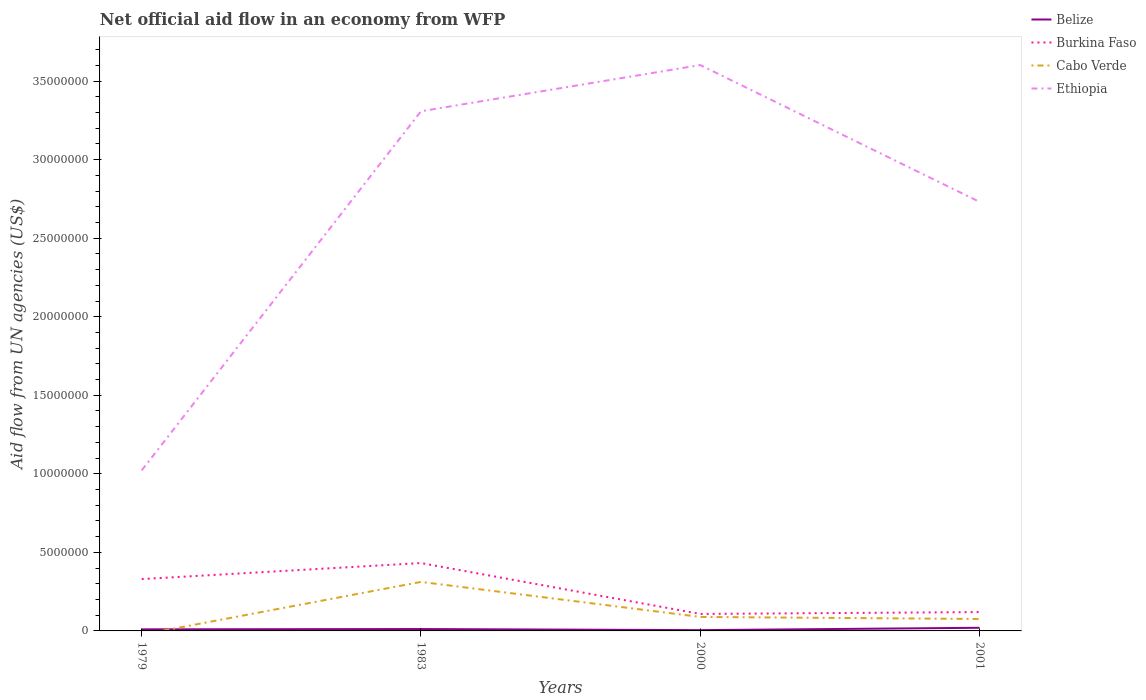Does the line corresponding to Cabo Verde intersect with the line corresponding to Belize?
Your answer should be very brief. Yes. Across all years, what is the maximum net official aid flow in Ethiopia?
Your answer should be very brief. 1.02e+07. What is the total net official aid flow in Burkina Faso in the graph?
Offer a terse response. 2.22e+06. What is the difference between the highest and the second highest net official aid flow in Burkina Faso?
Offer a terse response. 3.24e+06. What is the difference between the highest and the lowest net official aid flow in Belize?
Your response must be concise. 2. Is the net official aid flow in Burkina Faso strictly greater than the net official aid flow in Cabo Verde over the years?
Provide a succinct answer. No. How many lines are there?
Keep it short and to the point. 4. How many years are there in the graph?
Your answer should be very brief. 4. Does the graph contain grids?
Make the answer very short. No. How are the legend labels stacked?
Give a very brief answer. Vertical. What is the title of the graph?
Keep it short and to the point. Net official aid flow in an economy from WFP. Does "Israel" appear as one of the legend labels in the graph?
Your response must be concise. No. What is the label or title of the Y-axis?
Your response must be concise. Aid flow from UN agencies (US$). What is the Aid flow from UN agencies (US$) of Belize in 1979?
Your answer should be compact. 1.00e+05. What is the Aid flow from UN agencies (US$) in Burkina Faso in 1979?
Provide a short and direct response. 3.30e+06. What is the Aid flow from UN agencies (US$) of Ethiopia in 1979?
Your answer should be compact. 1.02e+07. What is the Aid flow from UN agencies (US$) in Burkina Faso in 1983?
Keep it short and to the point. 4.32e+06. What is the Aid flow from UN agencies (US$) in Cabo Verde in 1983?
Your response must be concise. 3.12e+06. What is the Aid flow from UN agencies (US$) in Ethiopia in 1983?
Your answer should be compact. 3.31e+07. What is the Aid flow from UN agencies (US$) of Belize in 2000?
Ensure brevity in your answer.  5.00e+04. What is the Aid flow from UN agencies (US$) of Burkina Faso in 2000?
Ensure brevity in your answer.  1.08e+06. What is the Aid flow from UN agencies (US$) of Cabo Verde in 2000?
Provide a short and direct response. 8.90e+05. What is the Aid flow from UN agencies (US$) of Ethiopia in 2000?
Ensure brevity in your answer.  3.60e+07. What is the Aid flow from UN agencies (US$) of Burkina Faso in 2001?
Your answer should be compact. 1.20e+06. What is the Aid flow from UN agencies (US$) in Cabo Verde in 2001?
Give a very brief answer. 7.60e+05. What is the Aid flow from UN agencies (US$) in Ethiopia in 2001?
Your response must be concise. 2.73e+07. Across all years, what is the maximum Aid flow from UN agencies (US$) in Belize?
Provide a short and direct response. 2.00e+05. Across all years, what is the maximum Aid flow from UN agencies (US$) of Burkina Faso?
Offer a very short reply. 4.32e+06. Across all years, what is the maximum Aid flow from UN agencies (US$) of Cabo Verde?
Offer a very short reply. 3.12e+06. Across all years, what is the maximum Aid flow from UN agencies (US$) of Ethiopia?
Ensure brevity in your answer.  3.60e+07. Across all years, what is the minimum Aid flow from UN agencies (US$) of Belize?
Provide a succinct answer. 5.00e+04. Across all years, what is the minimum Aid flow from UN agencies (US$) of Burkina Faso?
Make the answer very short. 1.08e+06. Across all years, what is the minimum Aid flow from UN agencies (US$) of Cabo Verde?
Your answer should be compact. 0. Across all years, what is the minimum Aid flow from UN agencies (US$) in Ethiopia?
Keep it short and to the point. 1.02e+07. What is the total Aid flow from UN agencies (US$) of Burkina Faso in the graph?
Your answer should be very brief. 9.90e+06. What is the total Aid flow from UN agencies (US$) of Cabo Verde in the graph?
Provide a short and direct response. 4.77e+06. What is the total Aid flow from UN agencies (US$) of Ethiopia in the graph?
Offer a terse response. 1.07e+08. What is the difference between the Aid flow from UN agencies (US$) of Burkina Faso in 1979 and that in 1983?
Your response must be concise. -1.02e+06. What is the difference between the Aid flow from UN agencies (US$) in Ethiopia in 1979 and that in 1983?
Your answer should be very brief. -2.29e+07. What is the difference between the Aid flow from UN agencies (US$) of Burkina Faso in 1979 and that in 2000?
Ensure brevity in your answer.  2.22e+06. What is the difference between the Aid flow from UN agencies (US$) in Ethiopia in 1979 and that in 2000?
Provide a short and direct response. -2.58e+07. What is the difference between the Aid flow from UN agencies (US$) in Burkina Faso in 1979 and that in 2001?
Give a very brief answer. 2.10e+06. What is the difference between the Aid flow from UN agencies (US$) in Ethiopia in 1979 and that in 2001?
Your answer should be very brief. -1.71e+07. What is the difference between the Aid flow from UN agencies (US$) of Belize in 1983 and that in 2000?
Offer a terse response. 7.00e+04. What is the difference between the Aid flow from UN agencies (US$) in Burkina Faso in 1983 and that in 2000?
Keep it short and to the point. 3.24e+06. What is the difference between the Aid flow from UN agencies (US$) in Cabo Verde in 1983 and that in 2000?
Your answer should be compact. 2.23e+06. What is the difference between the Aid flow from UN agencies (US$) of Ethiopia in 1983 and that in 2000?
Keep it short and to the point. -2.94e+06. What is the difference between the Aid flow from UN agencies (US$) in Burkina Faso in 1983 and that in 2001?
Ensure brevity in your answer.  3.12e+06. What is the difference between the Aid flow from UN agencies (US$) of Cabo Verde in 1983 and that in 2001?
Ensure brevity in your answer.  2.36e+06. What is the difference between the Aid flow from UN agencies (US$) of Ethiopia in 1983 and that in 2001?
Make the answer very short. 5.77e+06. What is the difference between the Aid flow from UN agencies (US$) in Cabo Verde in 2000 and that in 2001?
Your answer should be compact. 1.30e+05. What is the difference between the Aid flow from UN agencies (US$) of Ethiopia in 2000 and that in 2001?
Provide a short and direct response. 8.71e+06. What is the difference between the Aid flow from UN agencies (US$) in Belize in 1979 and the Aid flow from UN agencies (US$) in Burkina Faso in 1983?
Your response must be concise. -4.22e+06. What is the difference between the Aid flow from UN agencies (US$) in Belize in 1979 and the Aid flow from UN agencies (US$) in Cabo Verde in 1983?
Your answer should be compact. -3.02e+06. What is the difference between the Aid flow from UN agencies (US$) of Belize in 1979 and the Aid flow from UN agencies (US$) of Ethiopia in 1983?
Give a very brief answer. -3.30e+07. What is the difference between the Aid flow from UN agencies (US$) in Burkina Faso in 1979 and the Aid flow from UN agencies (US$) in Cabo Verde in 1983?
Ensure brevity in your answer.  1.80e+05. What is the difference between the Aid flow from UN agencies (US$) of Burkina Faso in 1979 and the Aid flow from UN agencies (US$) of Ethiopia in 1983?
Your answer should be compact. -2.98e+07. What is the difference between the Aid flow from UN agencies (US$) in Belize in 1979 and the Aid flow from UN agencies (US$) in Burkina Faso in 2000?
Offer a terse response. -9.80e+05. What is the difference between the Aid flow from UN agencies (US$) in Belize in 1979 and the Aid flow from UN agencies (US$) in Cabo Verde in 2000?
Give a very brief answer. -7.90e+05. What is the difference between the Aid flow from UN agencies (US$) of Belize in 1979 and the Aid flow from UN agencies (US$) of Ethiopia in 2000?
Offer a terse response. -3.59e+07. What is the difference between the Aid flow from UN agencies (US$) in Burkina Faso in 1979 and the Aid flow from UN agencies (US$) in Cabo Verde in 2000?
Give a very brief answer. 2.41e+06. What is the difference between the Aid flow from UN agencies (US$) of Burkina Faso in 1979 and the Aid flow from UN agencies (US$) of Ethiopia in 2000?
Provide a short and direct response. -3.27e+07. What is the difference between the Aid flow from UN agencies (US$) of Belize in 1979 and the Aid flow from UN agencies (US$) of Burkina Faso in 2001?
Provide a short and direct response. -1.10e+06. What is the difference between the Aid flow from UN agencies (US$) in Belize in 1979 and the Aid flow from UN agencies (US$) in Cabo Verde in 2001?
Your answer should be very brief. -6.60e+05. What is the difference between the Aid flow from UN agencies (US$) of Belize in 1979 and the Aid flow from UN agencies (US$) of Ethiopia in 2001?
Make the answer very short. -2.72e+07. What is the difference between the Aid flow from UN agencies (US$) of Burkina Faso in 1979 and the Aid flow from UN agencies (US$) of Cabo Verde in 2001?
Make the answer very short. 2.54e+06. What is the difference between the Aid flow from UN agencies (US$) of Burkina Faso in 1979 and the Aid flow from UN agencies (US$) of Ethiopia in 2001?
Your answer should be compact. -2.40e+07. What is the difference between the Aid flow from UN agencies (US$) in Belize in 1983 and the Aid flow from UN agencies (US$) in Burkina Faso in 2000?
Keep it short and to the point. -9.60e+05. What is the difference between the Aid flow from UN agencies (US$) of Belize in 1983 and the Aid flow from UN agencies (US$) of Cabo Verde in 2000?
Offer a terse response. -7.70e+05. What is the difference between the Aid flow from UN agencies (US$) in Belize in 1983 and the Aid flow from UN agencies (US$) in Ethiopia in 2000?
Make the answer very short. -3.59e+07. What is the difference between the Aid flow from UN agencies (US$) in Burkina Faso in 1983 and the Aid flow from UN agencies (US$) in Cabo Verde in 2000?
Keep it short and to the point. 3.43e+06. What is the difference between the Aid flow from UN agencies (US$) in Burkina Faso in 1983 and the Aid flow from UN agencies (US$) in Ethiopia in 2000?
Provide a succinct answer. -3.17e+07. What is the difference between the Aid flow from UN agencies (US$) in Cabo Verde in 1983 and the Aid flow from UN agencies (US$) in Ethiopia in 2000?
Ensure brevity in your answer.  -3.29e+07. What is the difference between the Aid flow from UN agencies (US$) of Belize in 1983 and the Aid flow from UN agencies (US$) of Burkina Faso in 2001?
Make the answer very short. -1.08e+06. What is the difference between the Aid flow from UN agencies (US$) in Belize in 1983 and the Aid flow from UN agencies (US$) in Cabo Verde in 2001?
Offer a very short reply. -6.40e+05. What is the difference between the Aid flow from UN agencies (US$) in Belize in 1983 and the Aid flow from UN agencies (US$) in Ethiopia in 2001?
Offer a very short reply. -2.72e+07. What is the difference between the Aid flow from UN agencies (US$) in Burkina Faso in 1983 and the Aid flow from UN agencies (US$) in Cabo Verde in 2001?
Offer a very short reply. 3.56e+06. What is the difference between the Aid flow from UN agencies (US$) of Burkina Faso in 1983 and the Aid flow from UN agencies (US$) of Ethiopia in 2001?
Provide a succinct answer. -2.30e+07. What is the difference between the Aid flow from UN agencies (US$) in Cabo Verde in 1983 and the Aid flow from UN agencies (US$) in Ethiopia in 2001?
Your response must be concise. -2.42e+07. What is the difference between the Aid flow from UN agencies (US$) of Belize in 2000 and the Aid flow from UN agencies (US$) of Burkina Faso in 2001?
Offer a very short reply. -1.15e+06. What is the difference between the Aid flow from UN agencies (US$) of Belize in 2000 and the Aid flow from UN agencies (US$) of Cabo Verde in 2001?
Your answer should be very brief. -7.10e+05. What is the difference between the Aid flow from UN agencies (US$) in Belize in 2000 and the Aid flow from UN agencies (US$) in Ethiopia in 2001?
Make the answer very short. -2.73e+07. What is the difference between the Aid flow from UN agencies (US$) of Burkina Faso in 2000 and the Aid flow from UN agencies (US$) of Ethiopia in 2001?
Offer a very short reply. -2.62e+07. What is the difference between the Aid flow from UN agencies (US$) in Cabo Verde in 2000 and the Aid flow from UN agencies (US$) in Ethiopia in 2001?
Provide a short and direct response. -2.64e+07. What is the average Aid flow from UN agencies (US$) of Belize per year?
Make the answer very short. 1.18e+05. What is the average Aid flow from UN agencies (US$) in Burkina Faso per year?
Your answer should be very brief. 2.48e+06. What is the average Aid flow from UN agencies (US$) of Cabo Verde per year?
Make the answer very short. 1.19e+06. What is the average Aid flow from UN agencies (US$) of Ethiopia per year?
Provide a succinct answer. 2.67e+07. In the year 1979, what is the difference between the Aid flow from UN agencies (US$) in Belize and Aid flow from UN agencies (US$) in Burkina Faso?
Provide a short and direct response. -3.20e+06. In the year 1979, what is the difference between the Aid flow from UN agencies (US$) of Belize and Aid flow from UN agencies (US$) of Ethiopia?
Ensure brevity in your answer.  -1.01e+07. In the year 1979, what is the difference between the Aid flow from UN agencies (US$) of Burkina Faso and Aid flow from UN agencies (US$) of Ethiopia?
Give a very brief answer. -6.92e+06. In the year 1983, what is the difference between the Aid flow from UN agencies (US$) of Belize and Aid flow from UN agencies (US$) of Burkina Faso?
Make the answer very short. -4.20e+06. In the year 1983, what is the difference between the Aid flow from UN agencies (US$) in Belize and Aid flow from UN agencies (US$) in Ethiopia?
Keep it short and to the point. -3.30e+07. In the year 1983, what is the difference between the Aid flow from UN agencies (US$) of Burkina Faso and Aid flow from UN agencies (US$) of Cabo Verde?
Make the answer very short. 1.20e+06. In the year 1983, what is the difference between the Aid flow from UN agencies (US$) of Burkina Faso and Aid flow from UN agencies (US$) of Ethiopia?
Keep it short and to the point. -2.88e+07. In the year 1983, what is the difference between the Aid flow from UN agencies (US$) of Cabo Verde and Aid flow from UN agencies (US$) of Ethiopia?
Keep it short and to the point. -3.00e+07. In the year 2000, what is the difference between the Aid flow from UN agencies (US$) in Belize and Aid flow from UN agencies (US$) in Burkina Faso?
Make the answer very short. -1.03e+06. In the year 2000, what is the difference between the Aid flow from UN agencies (US$) in Belize and Aid flow from UN agencies (US$) in Cabo Verde?
Your response must be concise. -8.40e+05. In the year 2000, what is the difference between the Aid flow from UN agencies (US$) in Belize and Aid flow from UN agencies (US$) in Ethiopia?
Provide a short and direct response. -3.60e+07. In the year 2000, what is the difference between the Aid flow from UN agencies (US$) of Burkina Faso and Aid flow from UN agencies (US$) of Ethiopia?
Ensure brevity in your answer.  -3.49e+07. In the year 2000, what is the difference between the Aid flow from UN agencies (US$) in Cabo Verde and Aid flow from UN agencies (US$) in Ethiopia?
Your answer should be very brief. -3.51e+07. In the year 2001, what is the difference between the Aid flow from UN agencies (US$) of Belize and Aid flow from UN agencies (US$) of Burkina Faso?
Offer a very short reply. -1.00e+06. In the year 2001, what is the difference between the Aid flow from UN agencies (US$) in Belize and Aid flow from UN agencies (US$) in Cabo Verde?
Offer a very short reply. -5.60e+05. In the year 2001, what is the difference between the Aid flow from UN agencies (US$) of Belize and Aid flow from UN agencies (US$) of Ethiopia?
Your answer should be compact. -2.71e+07. In the year 2001, what is the difference between the Aid flow from UN agencies (US$) of Burkina Faso and Aid flow from UN agencies (US$) of Ethiopia?
Your response must be concise. -2.61e+07. In the year 2001, what is the difference between the Aid flow from UN agencies (US$) of Cabo Verde and Aid flow from UN agencies (US$) of Ethiopia?
Your answer should be compact. -2.66e+07. What is the ratio of the Aid flow from UN agencies (US$) in Burkina Faso in 1979 to that in 1983?
Your response must be concise. 0.76. What is the ratio of the Aid flow from UN agencies (US$) of Ethiopia in 1979 to that in 1983?
Your answer should be very brief. 0.31. What is the ratio of the Aid flow from UN agencies (US$) of Burkina Faso in 1979 to that in 2000?
Offer a terse response. 3.06. What is the ratio of the Aid flow from UN agencies (US$) of Ethiopia in 1979 to that in 2000?
Offer a very short reply. 0.28. What is the ratio of the Aid flow from UN agencies (US$) of Belize in 1979 to that in 2001?
Offer a terse response. 0.5. What is the ratio of the Aid flow from UN agencies (US$) of Burkina Faso in 1979 to that in 2001?
Give a very brief answer. 2.75. What is the ratio of the Aid flow from UN agencies (US$) in Ethiopia in 1979 to that in 2001?
Ensure brevity in your answer.  0.37. What is the ratio of the Aid flow from UN agencies (US$) of Burkina Faso in 1983 to that in 2000?
Provide a short and direct response. 4. What is the ratio of the Aid flow from UN agencies (US$) of Cabo Verde in 1983 to that in 2000?
Your response must be concise. 3.51. What is the ratio of the Aid flow from UN agencies (US$) in Ethiopia in 1983 to that in 2000?
Make the answer very short. 0.92. What is the ratio of the Aid flow from UN agencies (US$) of Belize in 1983 to that in 2001?
Your answer should be very brief. 0.6. What is the ratio of the Aid flow from UN agencies (US$) of Cabo Verde in 1983 to that in 2001?
Give a very brief answer. 4.11. What is the ratio of the Aid flow from UN agencies (US$) in Ethiopia in 1983 to that in 2001?
Make the answer very short. 1.21. What is the ratio of the Aid flow from UN agencies (US$) of Belize in 2000 to that in 2001?
Your answer should be very brief. 0.25. What is the ratio of the Aid flow from UN agencies (US$) in Cabo Verde in 2000 to that in 2001?
Your response must be concise. 1.17. What is the ratio of the Aid flow from UN agencies (US$) of Ethiopia in 2000 to that in 2001?
Give a very brief answer. 1.32. What is the difference between the highest and the second highest Aid flow from UN agencies (US$) in Burkina Faso?
Keep it short and to the point. 1.02e+06. What is the difference between the highest and the second highest Aid flow from UN agencies (US$) of Cabo Verde?
Keep it short and to the point. 2.23e+06. What is the difference between the highest and the second highest Aid flow from UN agencies (US$) of Ethiopia?
Your answer should be very brief. 2.94e+06. What is the difference between the highest and the lowest Aid flow from UN agencies (US$) of Belize?
Give a very brief answer. 1.50e+05. What is the difference between the highest and the lowest Aid flow from UN agencies (US$) in Burkina Faso?
Provide a short and direct response. 3.24e+06. What is the difference between the highest and the lowest Aid flow from UN agencies (US$) of Cabo Verde?
Ensure brevity in your answer.  3.12e+06. What is the difference between the highest and the lowest Aid flow from UN agencies (US$) of Ethiopia?
Offer a very short reply. 2.58e+07. 